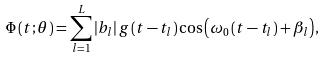<formula> <loc_0><loc_0><loc_500><loc_500>\Phi \left ( t ; \theta \right ) = \sum _ { l = 1 } ^ { L } { \left | b _ { l } \right | g \left ( t - t _ { l } \right ) \cos \left ( \omega _ { 0 } \left ( t - t _ { l } \right ) + \beta _ { l } \right ) } ,</formula> 